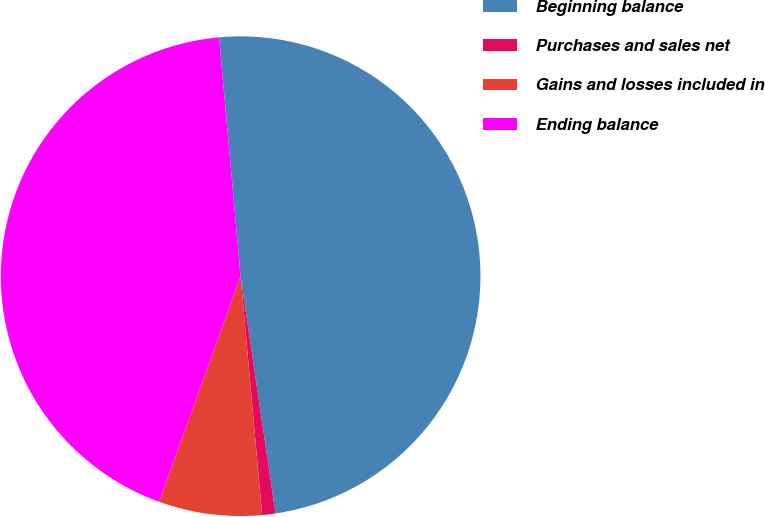<chart> <loc_0><loc_0><loc_500><loc_500><pie_chart><fcel>Beginning balance<fcel>Purchases and sales net<fcel>Gains and losses included in<fcel>Ending balance<nl><fcel>49.11%<fcel>0.89%<fcel>6.95%<fcel>43.05%<nl></chart> 